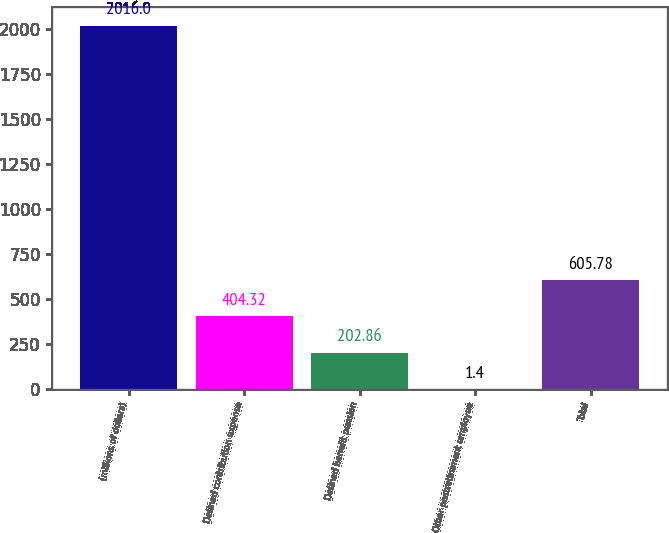Convert chart. <chart><loc_0><loc_0><loc_500><loc_500><bar_chart><fcel>(millions of dollars)<fcel>Defined contribution expense<fcel>Defined benefit pension<fcel>Other postretirement employee<fcel>Total<nl><fcel>2016<fcel>404.32<fcel>202.86<fcel>1.4<fcel>605.78<nl></chart> 